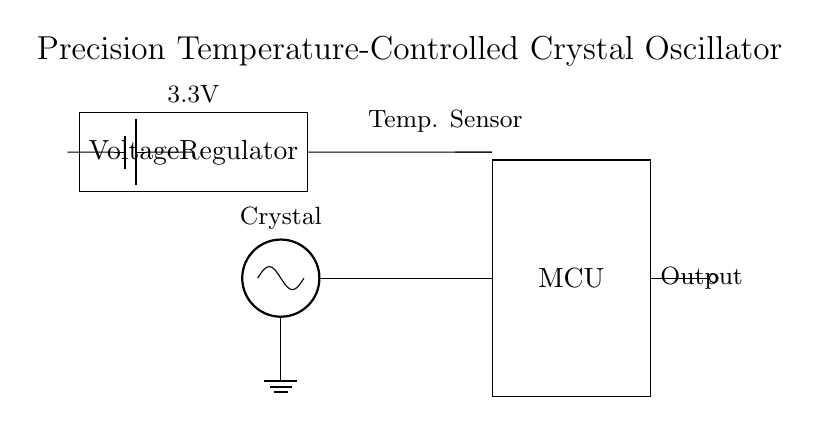What is the role of the crystal in this circuit? The crystal serves as the primary frequency-determining element in the oscillator, providing stable oscillations necessary for accurate timekeeping.
Answer: Frequency-determining element What is the output voltage of the voltage regulator? The voltage regulator is labeled as providing 3.3V, indicating the output voltage that would supply the microcontroller and other components.
Answer: 3.3V How is the temperature sensor connected in the circuit? The temperature sensor is connected to the microcontroller, allowing it to provide temperature feedback to maintain the precision of the oscillator through compensatory adjustments.
Answer: To the microcontroller What is the main purpose of including a microcontroller in the circuit? The microcontroller processes the signals from the crystal oscillator and the temperature sensor, coordinating the frequency adjustment for precision timekeeping.
Answer: Coordinating frequency adjustments Why is a temperature-controlled oscillator important in mobile devices? A temperature-controlled oscillator ensures accuracy in timekeeping by compensating for temperature variations that can affect the crystal's frequency, thus improving overall device performance.
Answer: Ensures accuracy What type of power source is used for this circuit? The circuit uses a battery as the power source, providing the necessary electrical energy for operation.
Answer: Battery What feature distinguishes this oscillator as a precision oscillator? The integration of a temperature sensor allows real-time adjustments to compensate for environmental changes, making it a precision oscillator.
Answer: Temperature sensor 